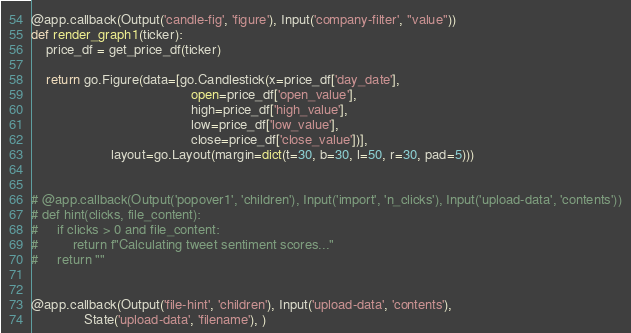<code> <loc_0><loc_0><loc_500><loc_500><_Python_>
@app.callback(Output('candle-fig', 'figure'), Input('company-filter', "value"))
def render_graph1(ticker):
    price_df = get_price_df(ticker)

    return go.Figure(data=[go.Candlestick(x=price_df['day_date'],
                                          open=price_df['open_value'],
                                          high=price_df['high_value'],
                                          low=price_df['low_value'],
                                          close=price_df['close_value'])],
                     layout=go.Layout(margin=dict(t=30, b=30, l=50, r=30, pad=5)))


# @app.callback(Output('popover1', 'children'), Input('import', 'n_clicks'), Input('upload-data', 'contents'))
# def hint(clicks, file_content):
#     if clicks > 0 and file_content:
#         return f"Calculating tweet sentiment scores..."
#     return ""


@app.callback(Output('file-hint', 'children'), Input('upload-data', 'contents'),
              State('upload-data', 'filename'), )</code> 